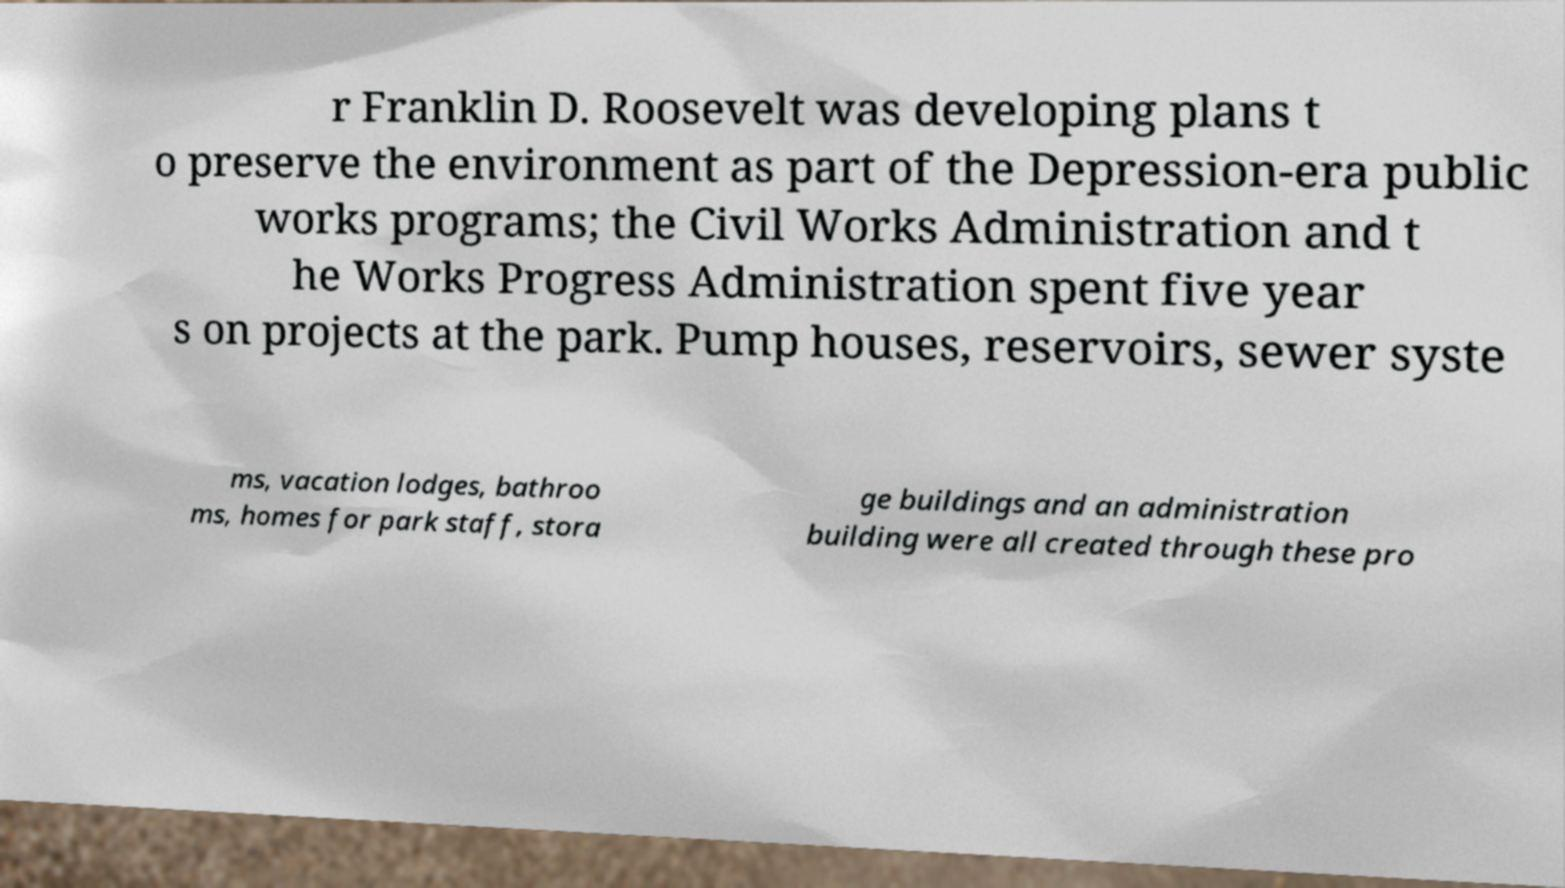Could you extract and type out the text from this image? r Franklin D. Roosevelt was developing plans t o preserve the environment as part of the Depression-era public works programs; the Civil Works Administration and t he Works Progress Administration spent five year s on projects at the park. Pump houses, reservoirs, sewer syste ms, vacation lodges, bathroo ms, homes for park staff, stora ge buildings and an administration building were all created through these pro 